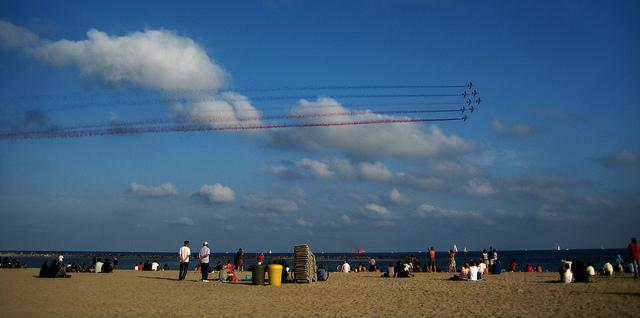How many colors are ejected from the planes flying in formation?

Choices:
A) four
B) five
C) six
D) seven five 